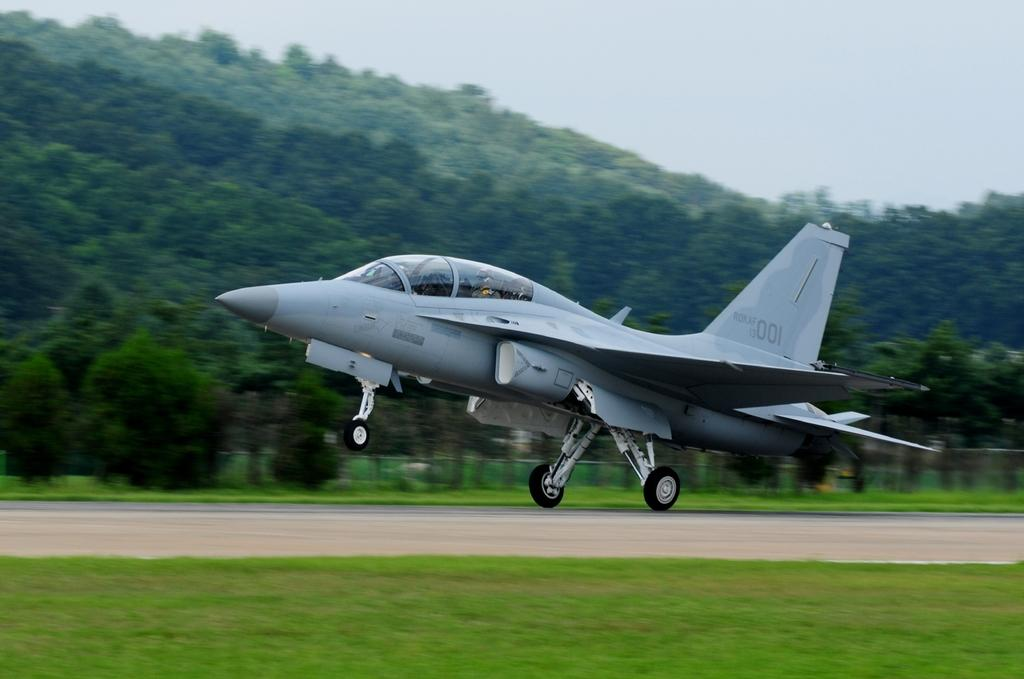<image>
Summarize the visual content of the image. A fighter jet is just taking off with the wing number 001. 